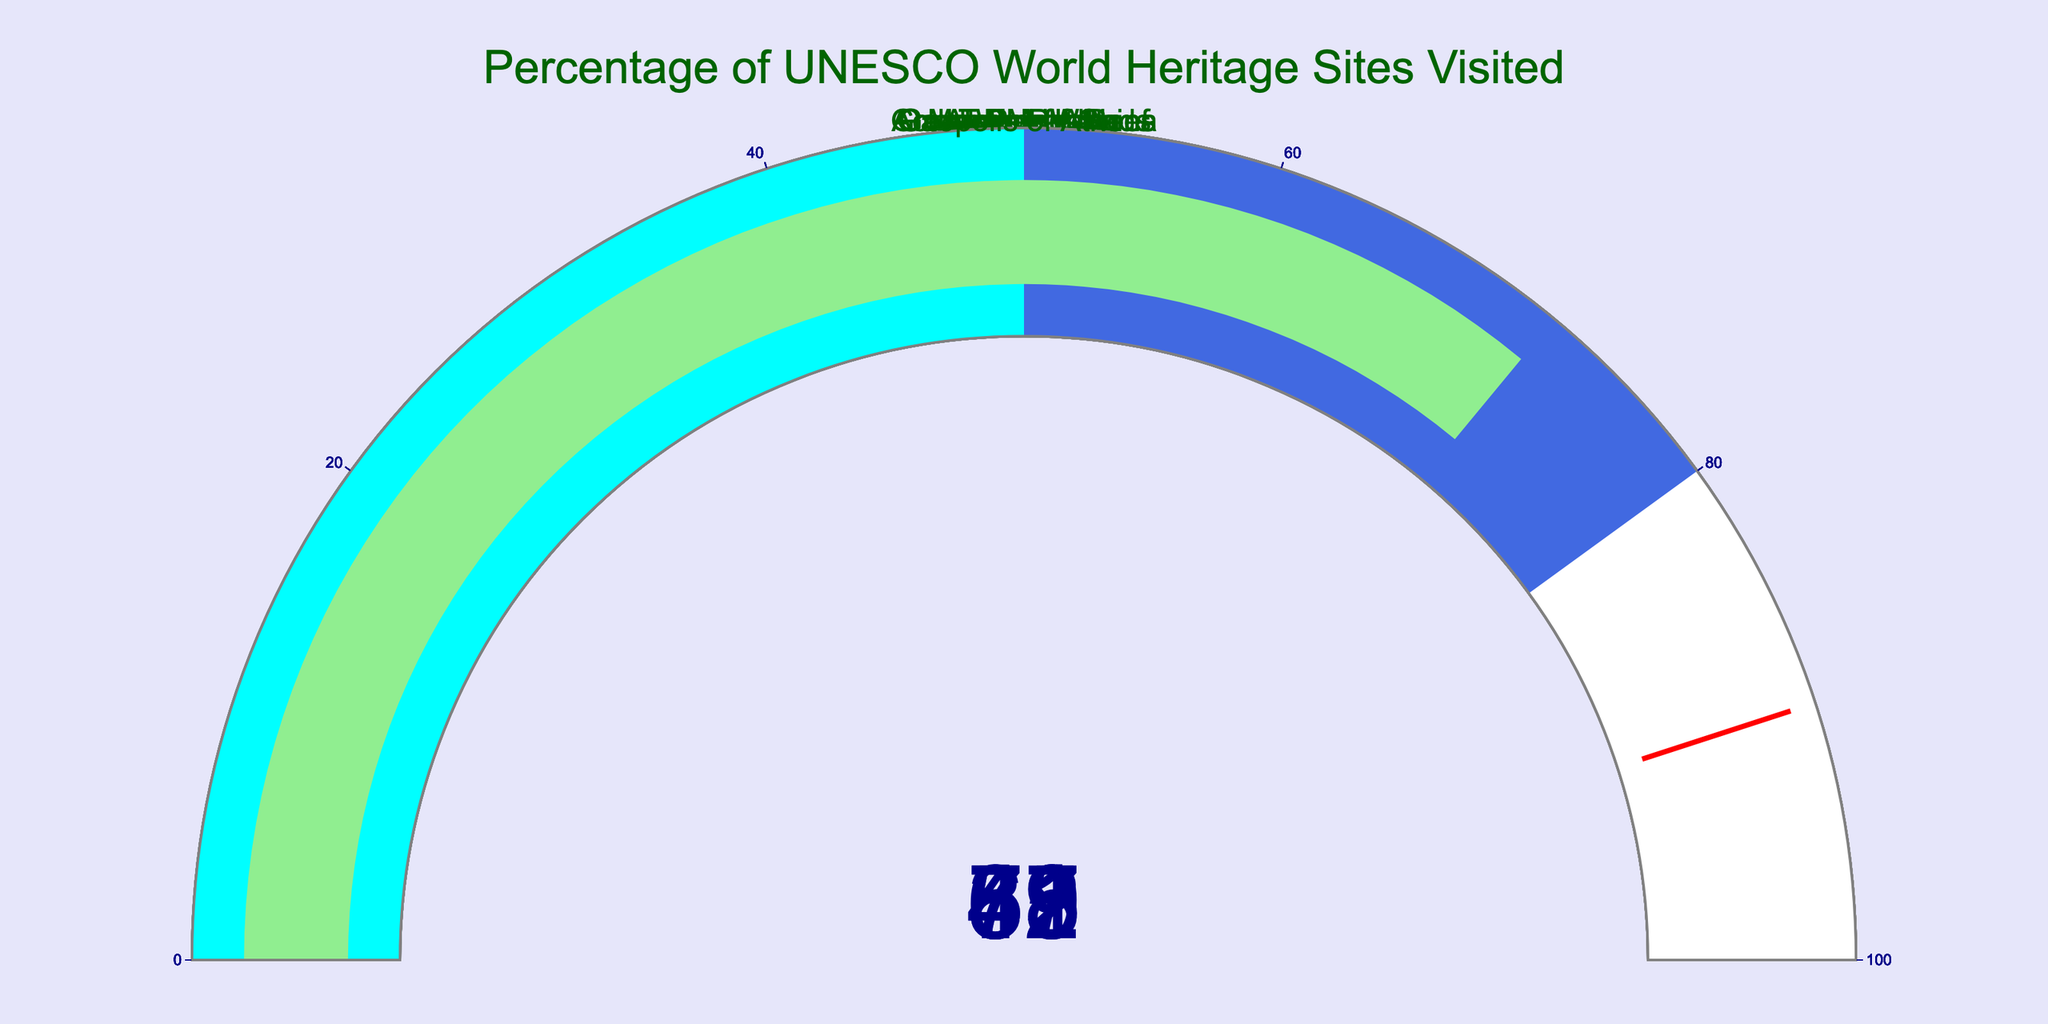What's the title of the figure? The title of the figure is written at the top of the chart. It reads "Percentage of UNESCO World Heritage Sites Visited".
Answer: Percentage of UNESCO World Heritage Sites Visited How many UNESCO World Heritage Sites are displayed in the figure? We can count the number of gauges in the chart. There are 8 gauges, each representing a different UNESCO World Heritage Site.
Answer: 8 Which UNESCO World Heritage Site has the highest percentage visited? By examining the values displayed on each gauge, we can see that "Taj Mahal" has the highest value at 87%.
Answer: Taj Mahal What is the average percentage of UNESCO World Heritage Sites visited? To find the average, sum all the percentages and divide by the number of sites. Sum is 78 + 65 + 52 + 43 + 87 + 31 + 59 + 72 = 487. There are 8 sites, so the average is 487 / 8 = 60.875.
Answer: 60.875 Which site has the lowest percentage visited and what is that percentage? By looking at the values, the "Galapagos Islands" has the lowest percentage visited, which is 31%.
Answer: Galapagos Islands, 31% How many sites have a percentage visited that is greater than 60%? By checking each gauge, we can see that there are 5 sites with percentages greater than 60: Machu Picchu (78%), Great Barrier Reef (65%), Taj Mahal (87%), Great Wall of China (59%), and Acropolis of Athens (72%).
Answer: 5 Is there any site with a percentage visited exactly equal to 50%? Checking each gauge, none of the sites have a percentage visited exactly equal to 50%.
Answer: No What is the difference in the percentage visited between "Machu Picchu" and "Petra"? Subtract the percentage of Petra from the percentage of Machu Picchu: 78% - 52% = 26%.
Answer: 26% What percentage of sites fall into the range [0%, 50%]? Based on the gauge colors and the percentage values, two sites fall into this range: Petra (52%) and Galapagos Islands (31%).
Answer: 2 What colors does the gauge indicating the percentage of the "Great Wall of China" contain? The gauge for the "Great Wall of China" includes the colors cyan for [0, 50] range and royalblue for [50, 80] range.
Answer: Cyan and royalblue 